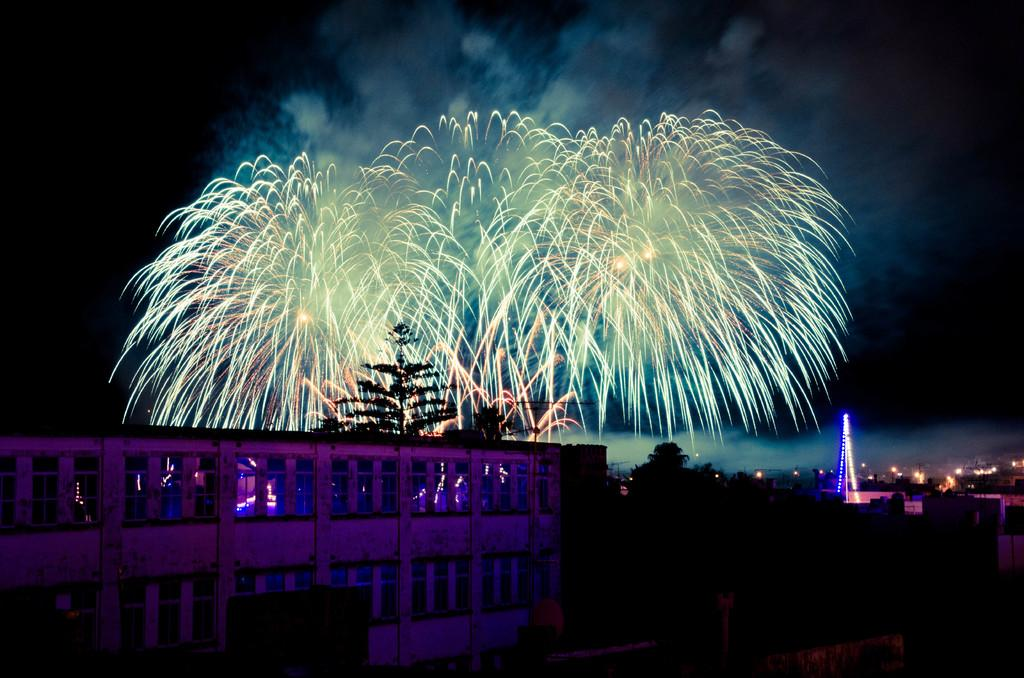What type of structure is visible in the image? There is a building in the image. What other elements can be seen in the image besides the building? There are trees in the image. What type of crime is being committed in the image? There is no crime being committed in the image; it only features a building and trees. How many potatoes are visible in the image? There are no potatoes present in the image. 